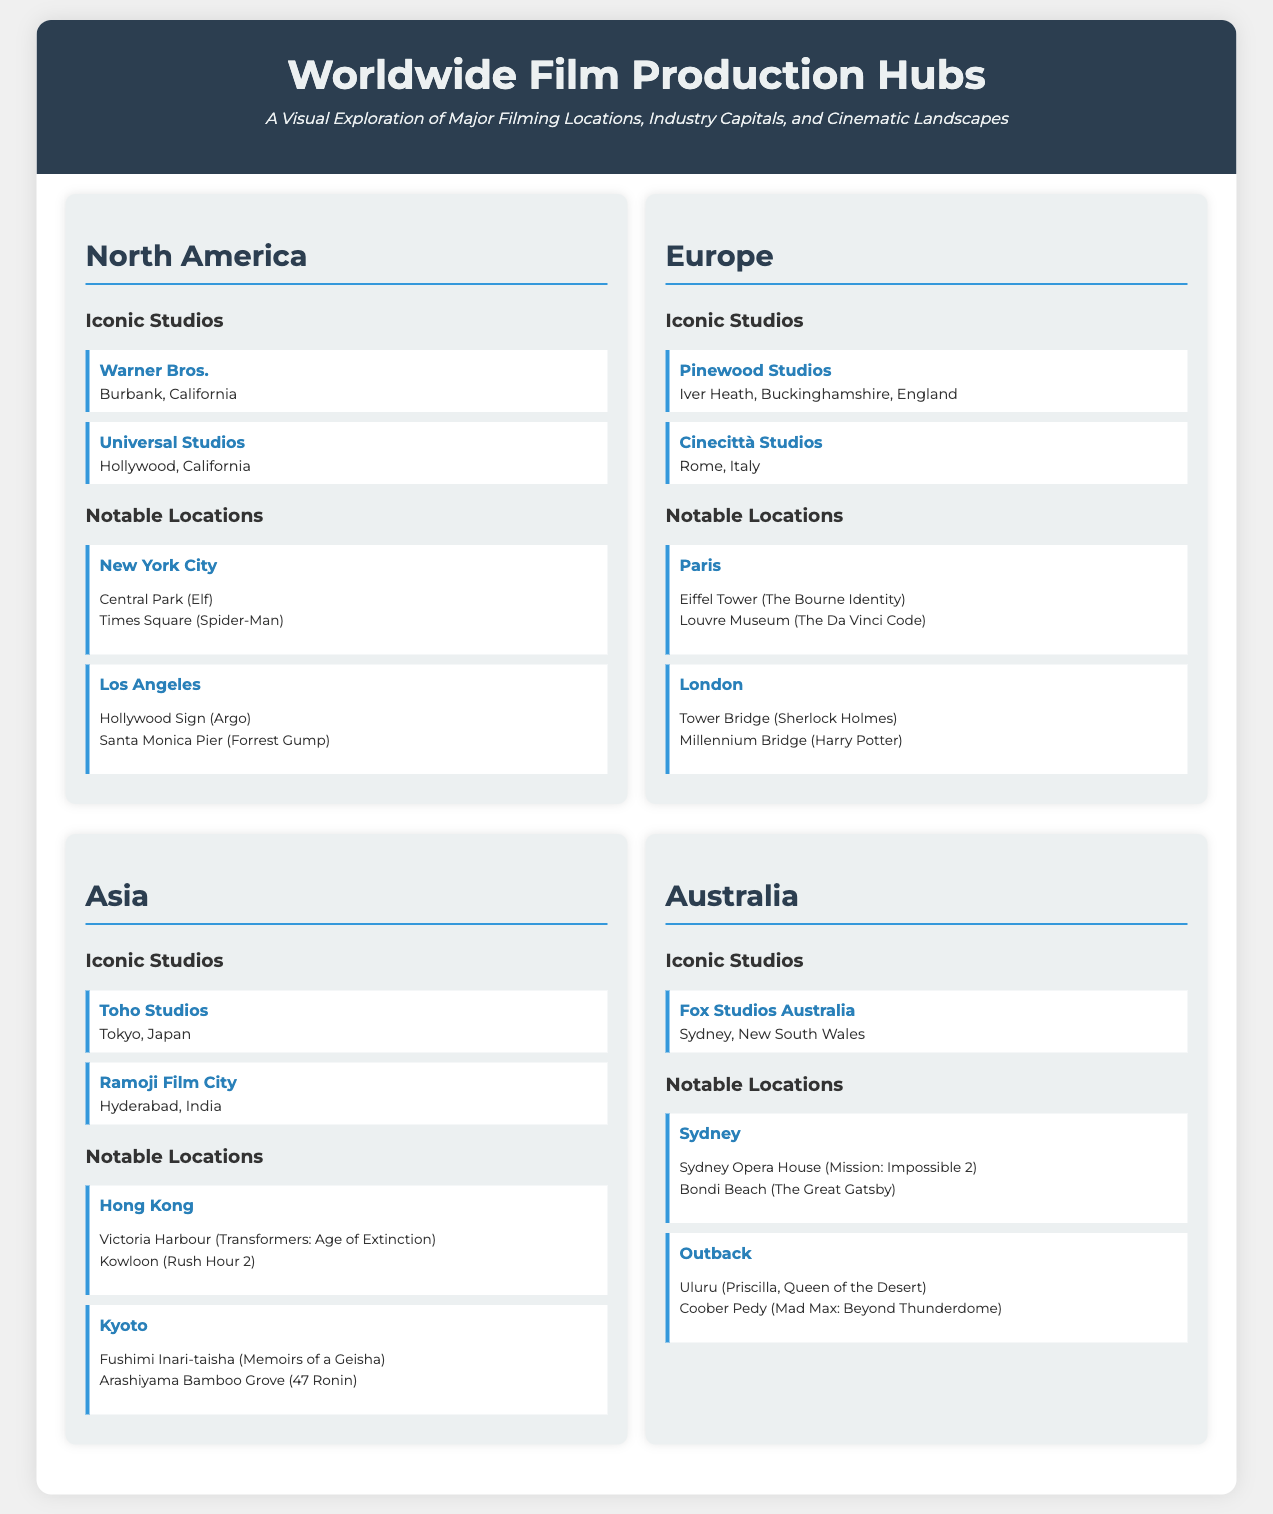what are two iconic studios in North America? The document lists Warner Bros. and Universal Studios as iconic studios in North America.
Answer: Warner Bros., Universal Studios which city is associated with the Eiffel Tower? The infographic lists Paris as the city where the Eiffel Tower is located.
Answer: Paris how many notable locations are listed for Asia? The document mentions two notable locations for Asia: Hong Kong and Kyoto.
Answer: 2 what is the main cinematic feature of Los Angeles mentioned? The Hollywood Sign is the main cinematic feature mentioned for Los Angeles.
Answer: Hollywood Sign which studio is located in Tokyo, Japan? The document identifies Toho Studios as the studio located in Tokyo.
Answer: Toho Studios what kind of reasoning connects the geographic locations to iconic movie scenes? The document shows how specific locations like the Sydney Opera House are featured in well-known films, highlighting the relationship between geography and cinema storytelling.
Answer: Geographic locations and iconic movie scenes how does the document categorize its content? The document categorizes its content by continents, each featuring its own studios and notable filming locations.
Answer: By continents what is the significance of Bondi Beach in the document? Bondi Beach is listed as a notable filming location in Sydney, emphasizing its cultural importance in cinema.
Answer: Notable filming location which studio is found in Rome, Italy? Cinecittà Studios is identified as the studio located in Rome, Italy.
Answer: Cinecittà Studios 